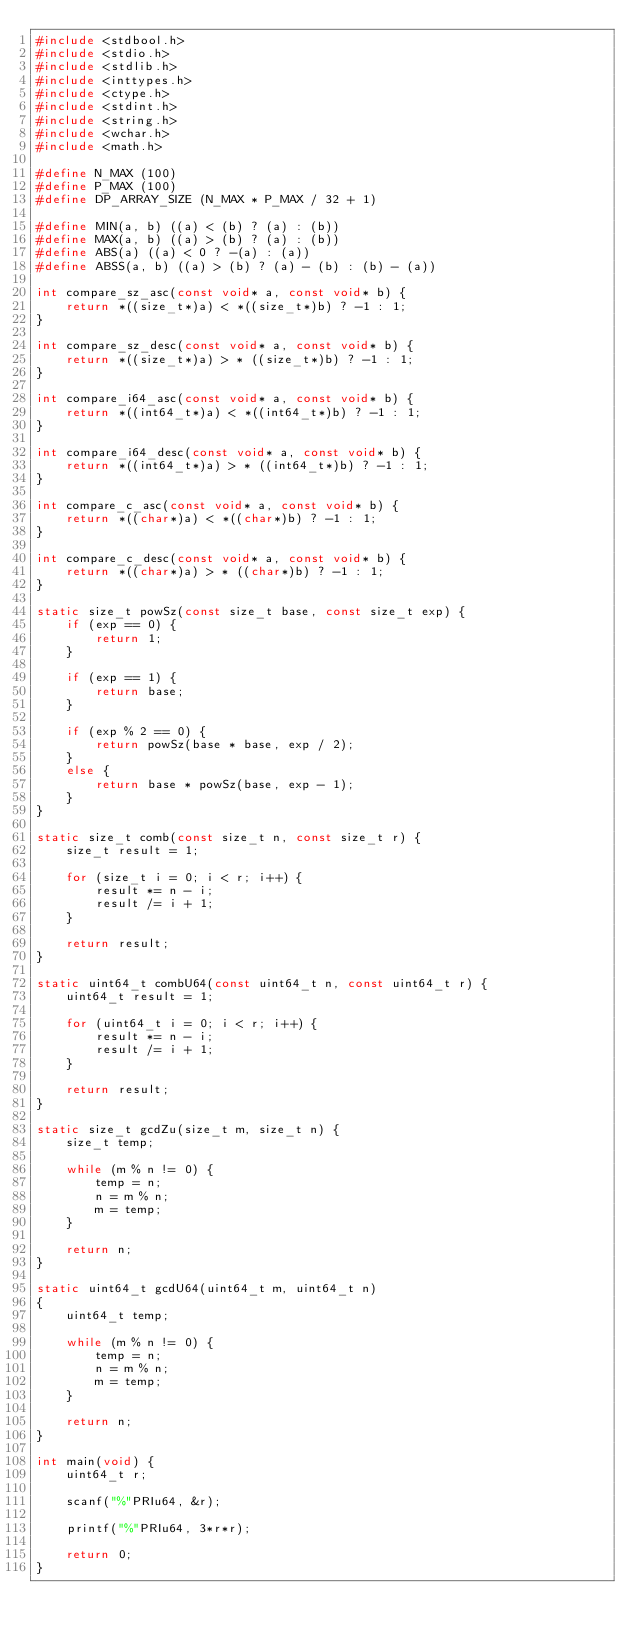Convert code to text. <code><loc_0><loc_0><loc_500><loc_500><_C_>#include <stdbool.h>
#include <stdio.h>
#include <stdlib.h>
#include <inttypes.h>
#include <ctype.h>
#include <stdint.h>
#include <string.h>
#include <wchar.h>
#include <math.h>

#define N_MAX (100)
#define P_MAX (100)
#define DP_ARRAY_SIZE (N_MAX * P_MAX / 32 + 1)

#define MIN(a, b) ((a) < (b) ? (a) : (b))
#define MAX(a, b) ((a) > (b) ? (a) : (b))
#define ABS(a) ((a) < 0 ? -(a) : (a))
#define ABSS(a, b) ((a) > (b) ? (a) - (b) : (b) - (a))

int compare_sz_asc(const void* a, const void* b) {
    return *((size_t*)a) < *((size_t*)b) ? -1 : 1;
}

int compare_sz_desc(const void* a, const void* b) {
    return *((size_t*)a) > * ((size_t*)b) ? -1 : 1;
}

int compare_i64_asc(const void* a, const void* b) {
    return *((int64_t*)a) < *((int64_t*)b) ? -1 : 1;
}

int compare_i64_desc(const void* a, const void* b) {
    return *((int64_t*)a) > * ((int64_t*)b) ? -1 : 1;
}

int compare_c_asc(const void* a, const void* b) {
    return *((char*)a) < *((char*)b) ? -1 : 1;
}

int compare_c_desc(const void* a, const void* b) {
    return *((char*)a) > * ((char*)b) ? -1 : 1;
}

static size_t powSz(const size_t base, const size_t exp) {
    if (exp == 0) {
        return 1;
    }

    if (exp == 1) {
        return base;
    }

    if (exp % 2 == 0) {
        return powSz(base * base, exp / 2);
    }
    else {
        return base * powSz(base, exp - 1);
    }
}

static size_t comb(const size_t n, const size_t r) {
    size_t result = 1;

    for (size_t i = 0; i < r; i++) {
        result *= n - i;
        result /= i + 1;
    }

    return result;
}

static uint64_t combU64(const uint64_t n, const uint64_t r) {
    uint64_t result = 1;

    for (uint64_t i = 0; i < r; i++) {
        result *= n - i;
        result /= i + 1;
    }

    return result;
}

static size_t gcdZu(size_t m, size_t n) {
    size_t temp;

    while (m % n != 0) {
        temp = n;
        n = m % n;
        m = temp;
    }

    return n;
}

static uint64_t gcdU64(uint64_t m, uint64_t n)
{
    uint64_t temp;

    while (m % n != 0) {
        temp = n;
        n = m % n;
        m = temp;
    }

    return n;
}

int main(void) {
    uint64_t r;

    scanf("%"PRIu64, &r);

    printf("%"PRIu64, 3*r*r);

    return 0;
}
</code> 